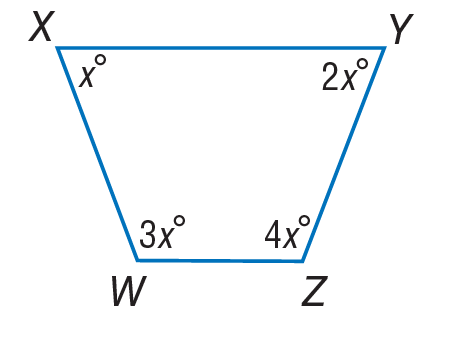Answer the mathemtical geometry problem and directly provide the correct option letter.
Question: Find m \angle X.
Choices: A: 18 B: 36 C: 72 D: 144 B 